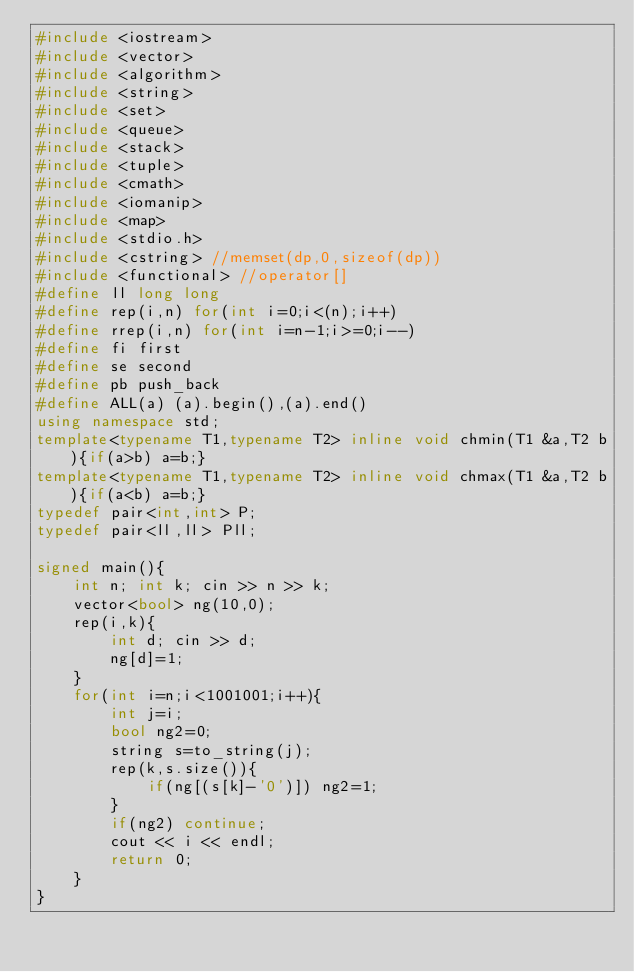<code> <loc_0><loc_0><loc_500><loc_500><_C++_>#include <iostream>
#include <vector>
#include <algorithm>
#include <string>
#include <set>
#include <queue>
#include <stack>
#include <tuple>
#include <cmath>
#include <iomanip>
#include <map>
#include <stdio.h>
#include <cstring> //memset(dp,0,sizeof(dp))
#include <functional> //operator[]
#define ll long long
#define rep(i,n) for(int i=0;i<(n);i++)
#define rrep(i,n) for(int i=n-1;i>=0;i--)
#define fi first
#define se second
#define pb push_back
#define ALL(a) (a).begin(),(a).end()
using namespace std;
template<typename T1,typename T2> inline void chmin(T1 &a,T2 b){if(a>b) a=b;}
template<typename T1,typename T2> inline void chmax(T1 &a,T2 b){if(a<b) a=b;}
typedef pair<int,int> P;
typedef pair<ll,ll> Pll;

signed main(){
    int n; int k; cin >> n >> k;
    vector<bool> ng(10,0);
    rep(i,k){
        int d; cin >> d;
        ng[d]=1;
    }
    for(int i=n;i<1001001;i++){
        int j=i;
        bool ng2=0;
        string s=to_string(j);
        rep(k,s.size()){
            if(ng[(s[k]-'0')]) ng2=1;
        }
        if(ng2) continue;
        cout << i << endl;
        return 0;
    }
}
</code> 